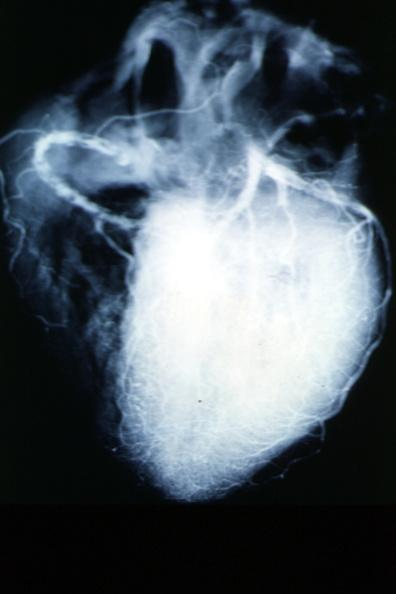what is present?
Answer the question using a single word or phrase. Angiogram 